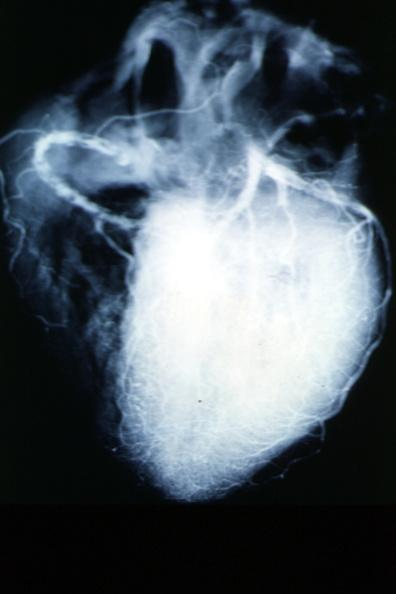what is present?
Answer the question using a single word or phrase. Angiogram 